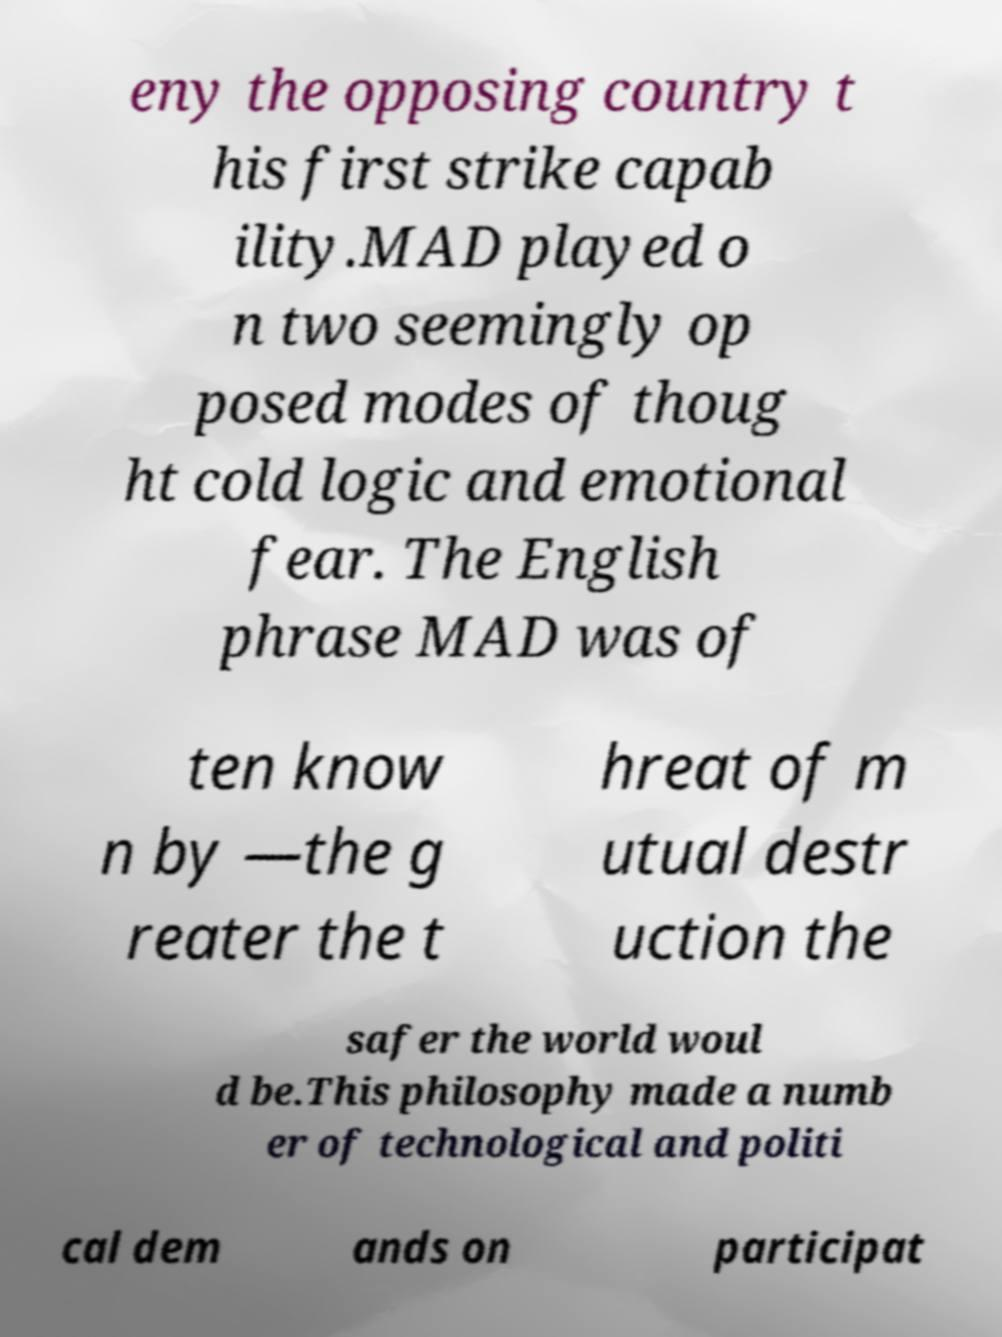Can you accurately transcribe the text from the provided image for me? eny the opposing country t his first strike capab ility.MAD played o n two seemingly op posed modes of thoug ht cold logic and emotional fear. The English phrase MAD was of ten know n by —the g reater the t hreat of m utual destr uction the safer the world woul d be.This philosophy made a numb er of technological and politi cal dem ands on participat 